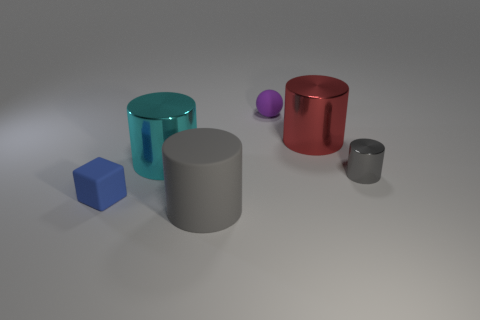What materials do these objects seem to be made of? The objects have various appearances that suggest different materials. The cyan and the red cylinders have a reflective metallic-like surface finish, possibly resembling materials such as anodized aluminum. The grey cylinders seem to have a matte surface, likely a touch of plastic or painted metal. And finally, the blue cube and the small purple sphere have a solid, consistent color that could be indicative of plastic or rubber. 